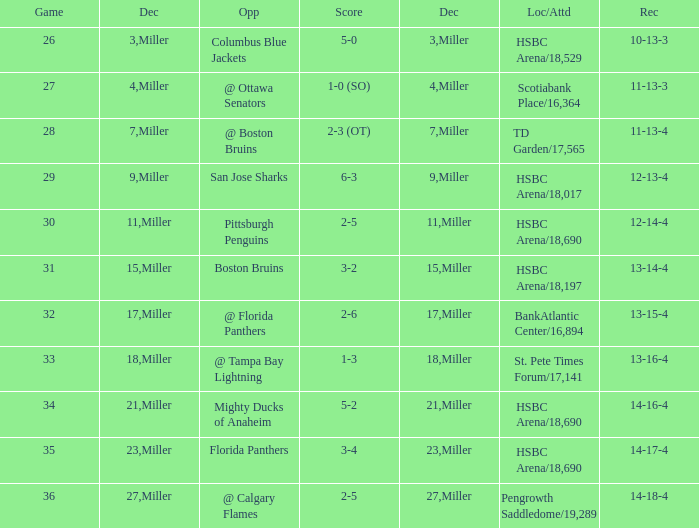Name the opponent for record 10-13-3 Columbus Blue Jackets. 